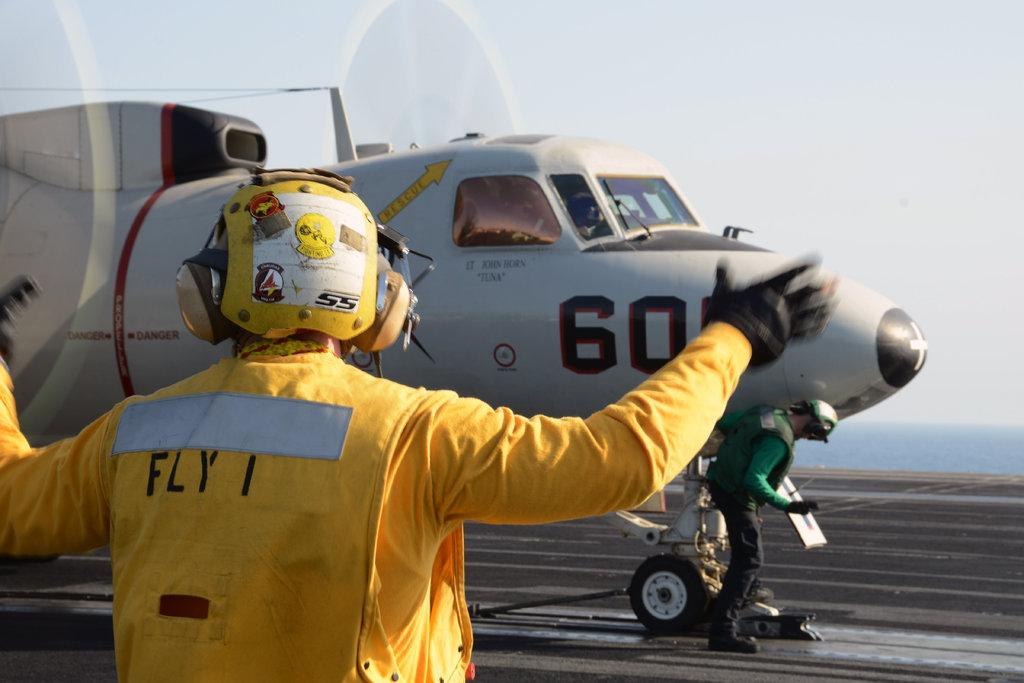Who is present in the image? There is a man in the image. What is the man wearing? The man is wearing a yellow dress and a helmet. What can be seen in the background of the image? There is an aeroplane in the background of the image, and it is on the road. What part of the natural environment is visible in the image? The sky is visible in the background of the image. What type of lock can be seen on the door of the house in the image? There is no house present in the image, so there is no door or lock to observe. 